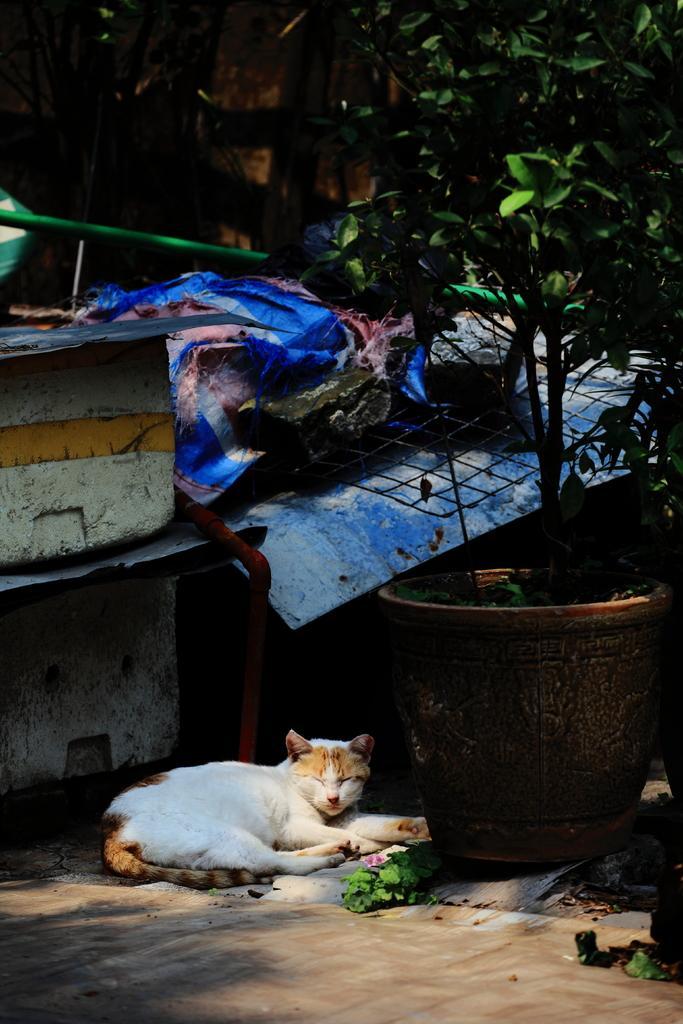In one or two sentences, can you explain what this image depicts? In this image, we can see a cat is laying on the ground. Here we can see mesh, plant with pot, few objects, clothes, rod. Background there is a wall. 